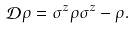Convert formula to latex. <formula><loc_0><loc_0><loc_500><loc_500>\mathcal { D } \rho = \sigma ^ { z } \rho \sigma ^ { z } - \rho .</formula> 